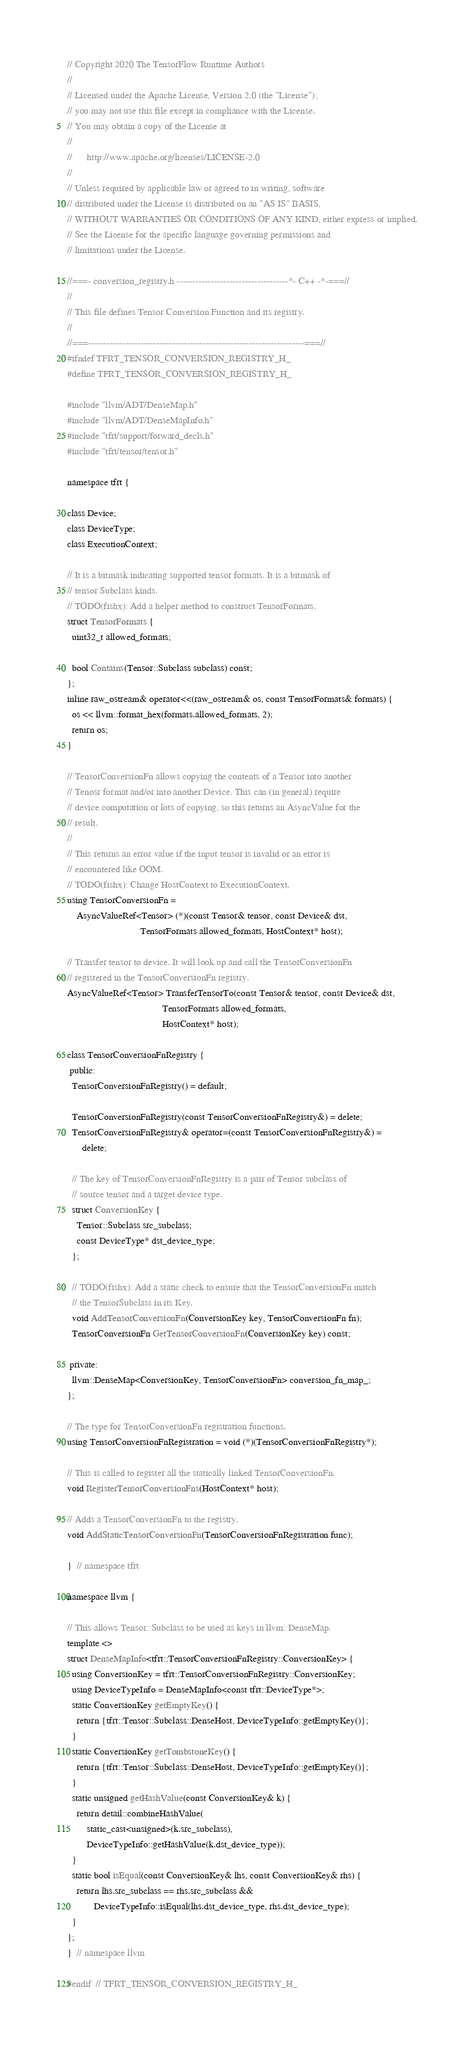<code> <loc_0><loc_0><loc_500><loc_500><_C_>// Copyright 2020 The TensorFlow Runtime Authors
//
// Licensed under the Apache License, Version 2.0 (the "License");
// you may not use this file except in compliance with the License.
// You may obtain a copy of the License at
//
//      http://www.apache.org/licenses/LICENSE-2.0
//
// Unless required by applicable law or agreed to in writing, software
// distributed under the License is distributed on an "AS IS" BASIS,
// WITHOUT WARRANTIES OR CONDITIONS OF ANY KIND, either express or implied.
// See the License for the specific language governing permissions and
// limitations under the License.

//===- conversion_registry.h ------------------------------------*- C++ -*-===//
//
// This file defines Tensor Conversion Function and its registry.
//
//===----------------------------------------------------------------------===//
#ifndef TFRT_TENSOR_CONVERSION_REGISTRY_H_
#define TFRT_TENSOR_CONVERSION_REGISTRY_H_

#include "llvm/ADT/DenseMap.h"
#include "llvm/ADT/DenseMapInfo.h"
#include "tfrt/support/forward_decls.h"
#include "tfrt/tensor/tensor.h"

namespace tfrt {

class Device;
class DeviceType;
class ExecutionContext;

// It is a bitmask indicating supported tensor formats. It is a bitmask of
// tensor Subclass kinds.
// TODO(fishx): Add a helper method to construct TensorFormats.
struct TensorFormats {
  uint32_t allowed_formats;

  bool Contains(Tensor::Subclass subclass) const;
};
inline raw_ostream& operator<<(raw_ostream& os, const TensorFormats& formats) {
  os << llvm::format_hex(formats.allowed_formats, 2);
  return os;
}

// TensorConversionFn allows copying the contents of a Tensor into another
// Tenosr format and/or into another Device. This can (in general) require
// device computation or lots of copying, so this returns an AsyncValue for the
// result.
//
// This returns an error value if the input tensor is invalid or an error is
// encountered like OOM.
// TODO(fishx): Change HostContext to ExecutionContext.
using TensorConversionFn =
    AsyncValueRef<Tensor> (*)(const Tensor& tensor, const Device& dst,
                              TensorFormats allowed_formats, HostContext* host);

// Transfer tensor to device. It will look up and call the TensorConversionFn
// registered in the TensorConversionFn registry.
AsyncValueRef<Tensor> TransferTensorTo(const Tensor& tensor, const Device& dst,
                                       TensorFormats allowed_formats,
                                       HostContext* host);

class TensorConversionFnRegistry {
 public:
  TensorConversionFnRegistry() = default;

  TensorConversionFnRegistry(const TensorConversionFnRegistry&) = delete;
  TensorConversionFnRegistry& operator=(const TensorConversionFnRegistry&) =
      delete;

  // The key of TensorConversionFnRegistry is a pair of Tensor subclass of
  // source tensor and a target device type.
  struct ConversionKey {
    Tensor::Subclass src_subclass;
    const DeviceType* dst_device_type;
  };

  // TODO(fishx): Add a static check to ensure that the TensorConversionFn match
  // the TensorSubclass in its Key.
  void AddTensorConversionFn(ConversionKey key, TensorConversionFn fn);
  TensorConversionFn GetTensorConversionFn(ConversionKey key) const;

 private:
  llvm::DenseMap<ConversionKey, TensorConversionFn> conversion_fn_map_;
};

// The type for TensorConversionFn registration functions.
using TensorConversionFnRegistration = void (*)(TensorConversionFnRegistry*);

// This is called to register all the statically linked TensorConversionFn.
void RegisterTensorConversionFns(HostContext* host);

// Adds a TensorConversionFn to the registry.
void AddStaticTensorConversionFn(TensorConversionFnRegistration func);

}  // namespace tfrt

namespace llvm {

// This allows Tensor::Subclass to be used as keys in llvm::DenseMap.
template <>
struct DenseMapInfo<tfrt::TensorConversionFnRegistry::ConversionKey> {
  using ConversionKey = tfrt::TensorConversionFnRegistry::ConversionKey;
  using DeviceTypeInfo = DenseMapInfo<const tfrt::DeviceType*>;
  static ConversionKey getEmptyKey() {
    return {tfrt::Tensor::Subclass::DenseHost, DeviceTypeInfo::getEmptyKey()};
  }
  static ConversionKey getTombstoneKey() {
    return {tfrt::Tensor::Subclass::DenseHost, DeviceTypeInfo::getEmptyKey()};
  }
  static unsigned getHashValue(const ConversionKey& k) {
    return detail::combineHashValue(
        static_cast<unsigned>(k.src_subclass),
        DeviceTypeInfo::getHashValue(k.dst_device_type));
  }
  static bool isEqual(const ConversionKey& lhs, const ConversionKey& rhs) {
    return lhs.src_subclass == rhs.src_subclass &&
           DeviceTypeInfo::isEqual(lhs.dst_device_type, rhs.dst_device_type);
  }
};
}  // namespace llvm

#endif  // TFRT_TENSOR_CONVERSION_REGISTRY_H_
</code> 